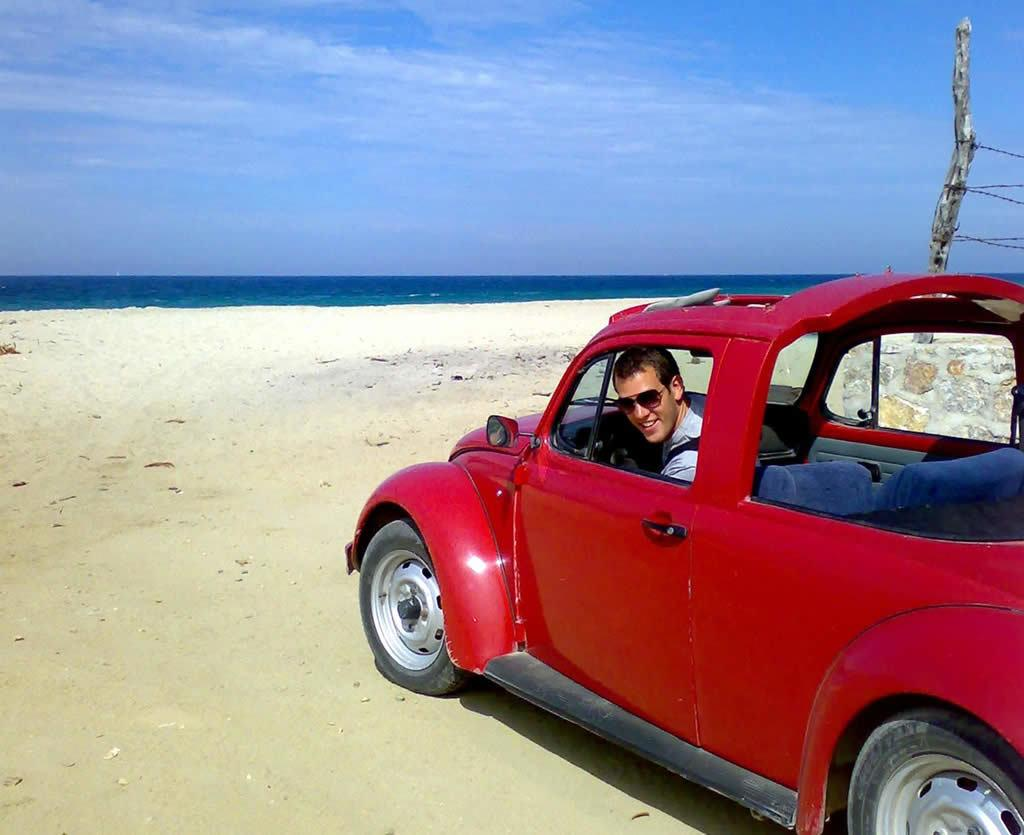What is the main subject of the image? The main subject of the image is a man. Where is the man located in the image? The man is inside a car. What can be seen on the man's face in the image? The man is wearing spectacles. What type of natural feature is visible in the image? There is a body of water, likely to be a sea, visible in the image. What is visible in the background of the image? There is a sky visible in the background of the image. What type of hen can be seen sitting on a branch in the image? There is no hen or branch present in the image; it features a man inside a car near a body of water. 